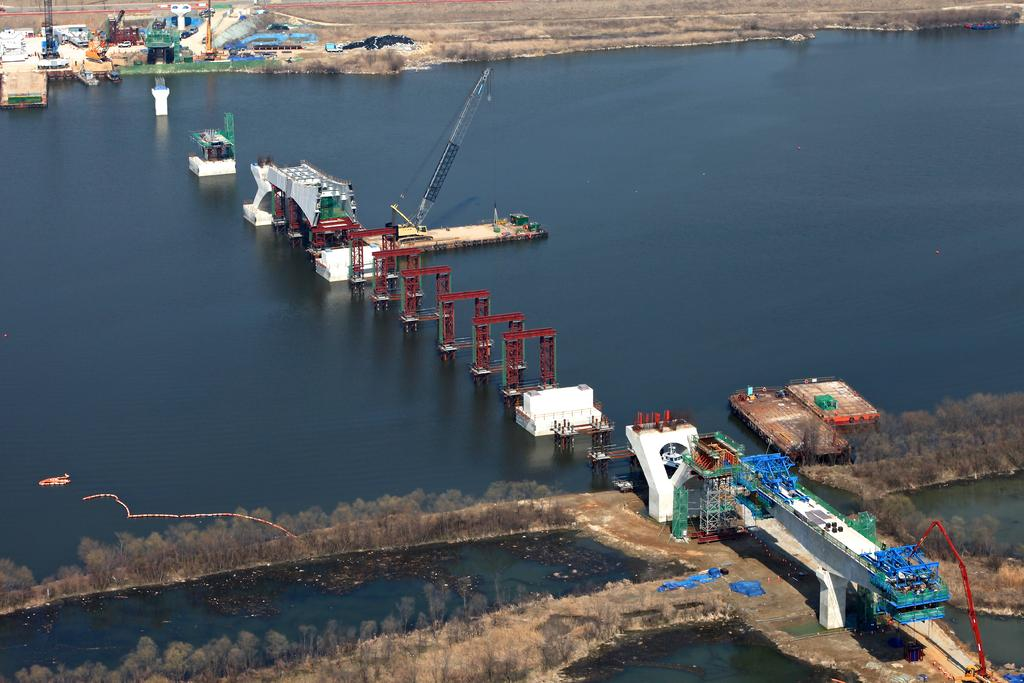What type of vegetation can be seen in the image? There are trees in the image. What is located in the water in the image? There are pillars in the water. What is the main structure in the middle of the image? There is a crane in the middle of the image. What can be seen in the top left corner of the image? There are objects in the top left of the image. What type of cactus can be seen in the image? There is no cactus present in the image; it features trees, pillars, a crane, and objects. What flavor of jam is being used to paint the pillars in the image? There is no jam present in the image; it features trees, pillars, a crane, and objects. 